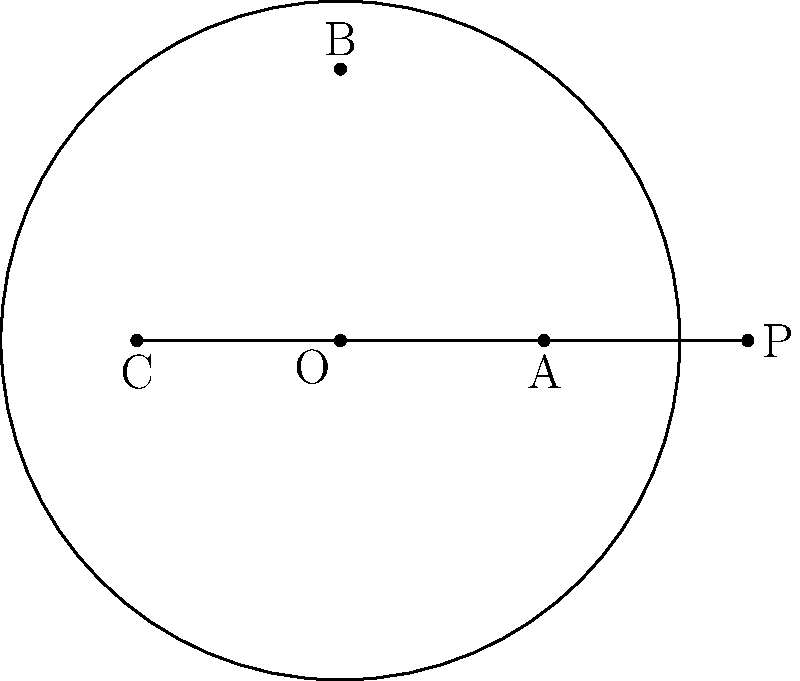In the diagram, two tangent lines are drawn from point P to a circle with center O. The tangent lines touch the circle at points A and C. If the radius of the circle is 5 units and OP = 11 units, what is the measure of angle APC? Let's approach this step-by-step:

1) In a circle, a tangent line is always perpendicular to the radius drawn to the point of tangency. This means that triangles OAP and OCP are both right-angled triangles.

2) In a right-angled triangle, we can use the Pythagorean theorem. Let's focus on triangle OAP:

   $OP^2 = OA^2 + AP^2$

3) We know that OP = 11 and OA (the radius) = 5. Let's substitute these values:

   $11^2 = 5^2 + AP^2$
   $121 = 25 + AP^2$
   $AP^2 = 96$
   $AP = \sqrt{96} = 4\sqrt{6}$

4) Now, we can find the sine of half of angle APC:

   $\sin(\frac{1}{2}APC) = \frac{OA}{OP} = \frac{5}{11}$

5) To find the full angle, we need to use the arcsine function and multiply by 2:

   $APC = 2 \cdot \arcsin(\frac{5}{11})$

6) Using a calculator or computer, we can evaluate this:

   $APC \approx 2 \cdot 27.0074° = 54.0148°$

Therefore, the measure of angle APC is approximately 54.01°.
Answer: $54.01°$ 